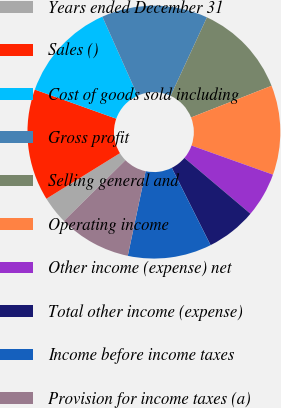<chart> <loc_0><loc_0><loc_500><loc_500><pie_chart><fcel>Years ended December 31<fcel>Sales ()<fcel>Cost of goods sold including<fcel>Gross profit<fcel>Selling general and<fcel>Operating income<fcel>Other income (expense) net<fcel>Total other income (expense)<fcel>Income before income taxes<fcel>Provision for income taxes (a)<nl><fcel>3.57%<fcel>14.29%<fcel>12.86%<fcel>13.57%<fcel>12.14%<fcel>11.43%<fcel>5.71%<fcel>6.43%<fcel>10.71%<fcel>9.29%<nl></chart> 